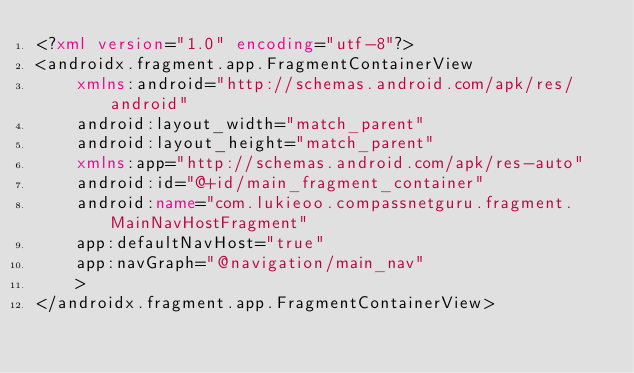Convert code to text. <code><loc_0><loc_0><loc_500><loc_500><_XML_><?xml version="1.0" encoding="utf-8"?>
<androidx.fragment.app.FragmentContainerView
    xmlns:android="http://schemas.android.com/apk/res/android"
    android:layout_width="match_parent"
    android:layout_height="match_parent"
    xmlns:app="http://schemas.android.com/apk/res-auto"
    android:id="@+id/main_fragment_container"
    android:name="com.lukieoo.compassnetguru.fragment.MainNavHostFragment"
    app:defaultNavHost="true"
    app:navGraph="@navigation/main_nav"
    >
</androidx.fragment.app.FragmentContainerView></code> 